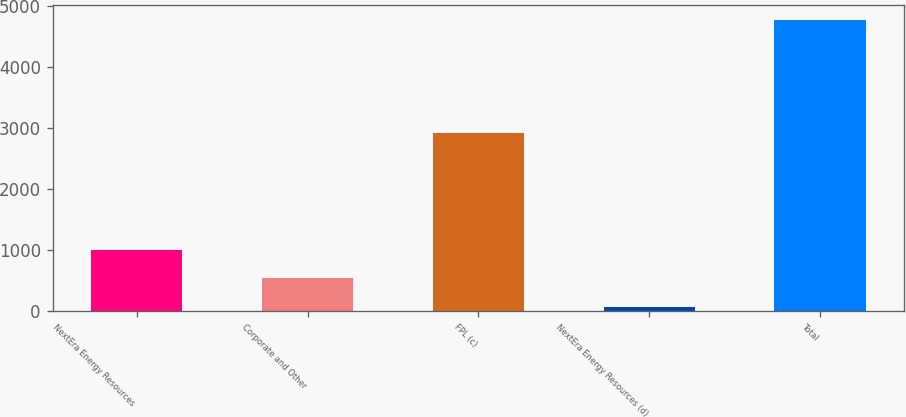<chart> <loc_0><loc_0><loc_500><loc_500><bar_chart><fcel>NextEra Energy Resources<fcel>Corporate and Other<fcel>FPL (c)<fcel>NextEra Energy Resources (d)<fcel>Total<nl><fcel>1001.2<fcel>530.6<fcel>2920<fcel>60<fcel>4766<nl></chart> 